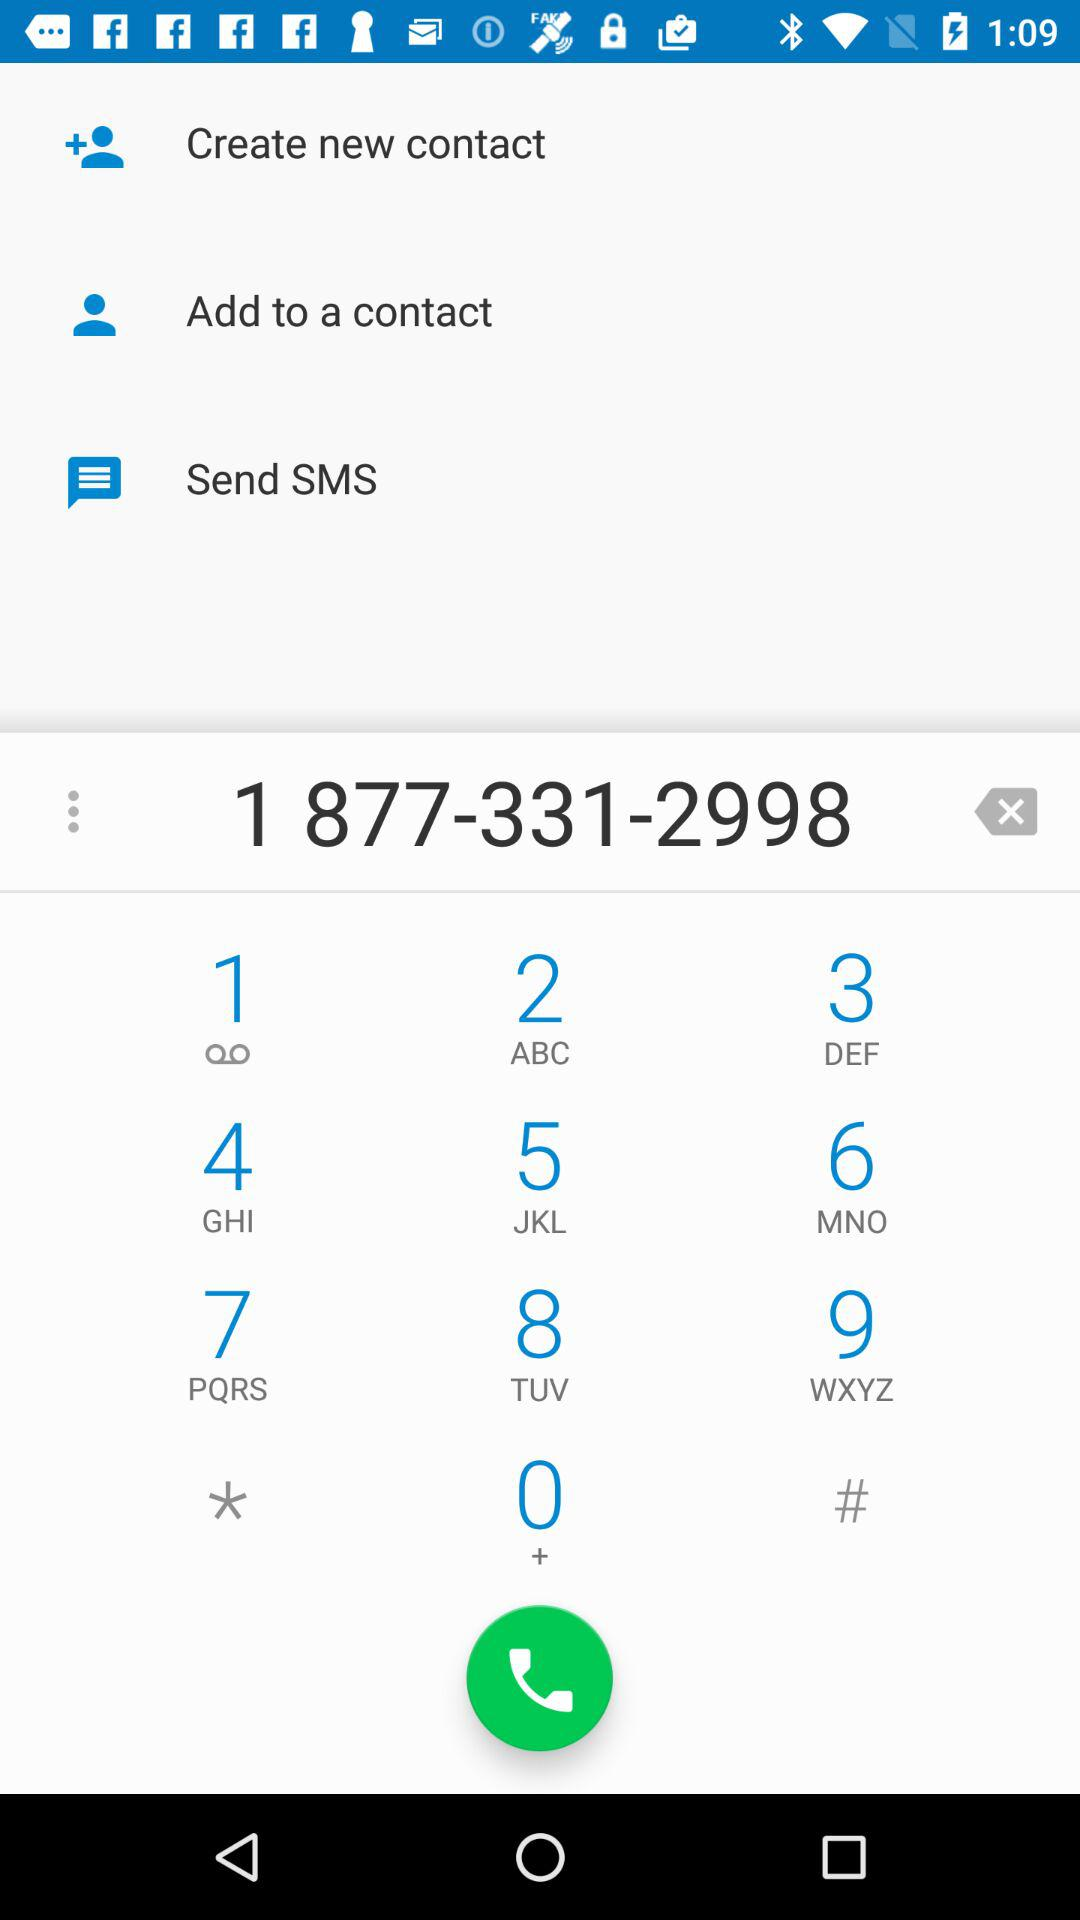What is the phone number? The phone number is 1 877-331-2998. 